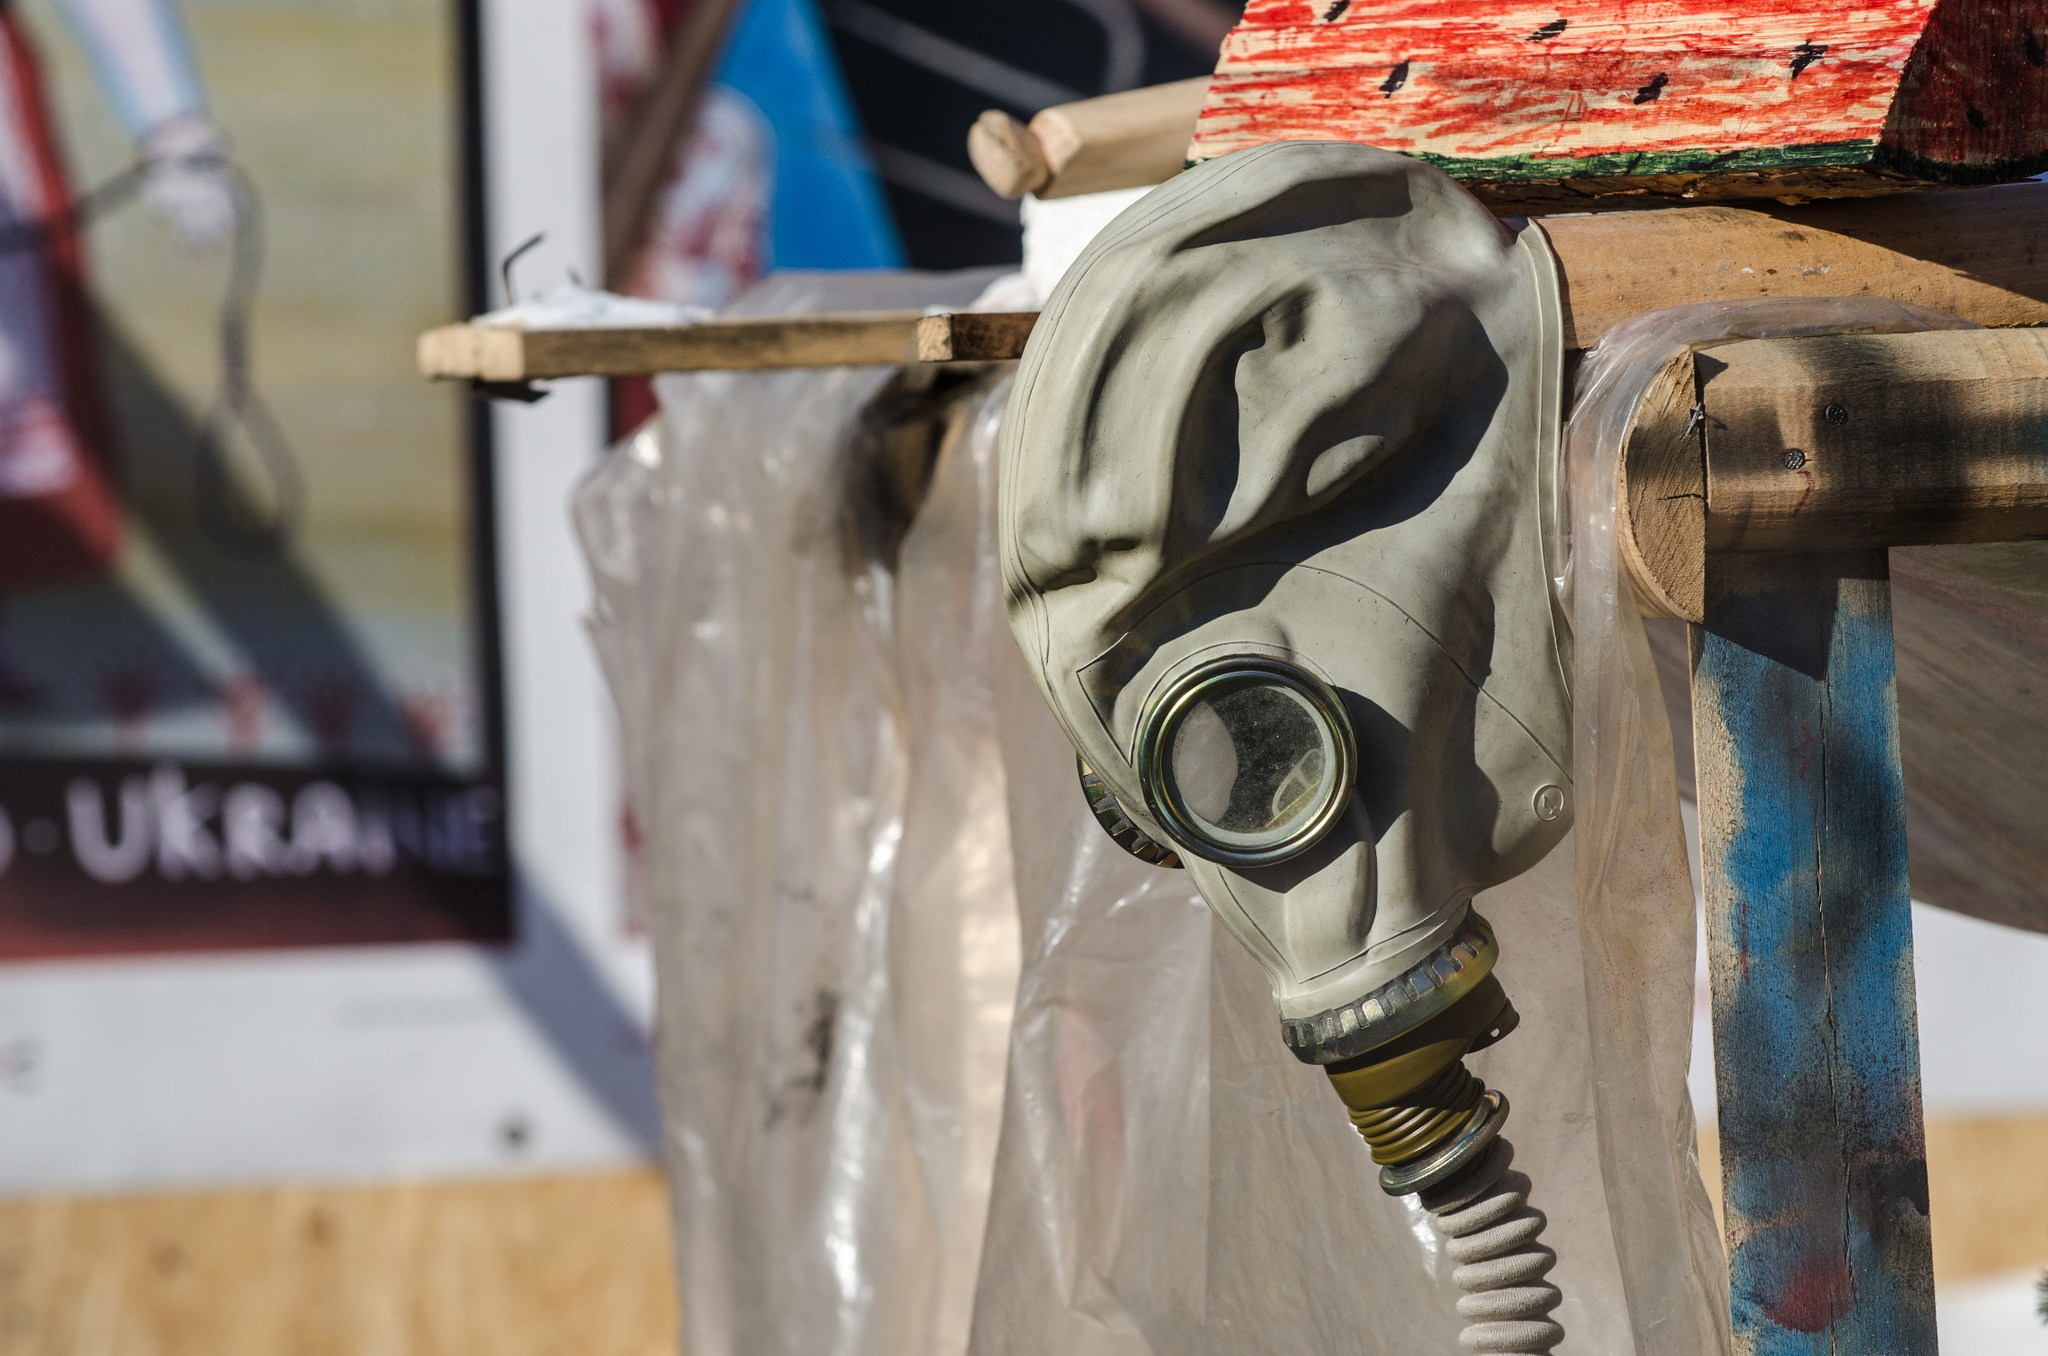Describe the following image. The image displays a green gas mask with an attached hose, hanging from a crudely made wooden support, which seems weathered and is painted in patches of red and blue. The mask is the focal point of the composition. In the background, there is a poster with Cyrillic text, topped by a Ukrainian flag, which provides a cultural backdrop and suggests a location within Ukraine or a context involving Ukrainian identity. The setup might be part of an outdoor exhibition or a commemorative display, hinting at historical or contemporary events related to military or civil defense. The details of the gas mask and the contrasting vibrant colors of the wooden support against the subdued backdrop invite reflections on resilience and remembrance. 